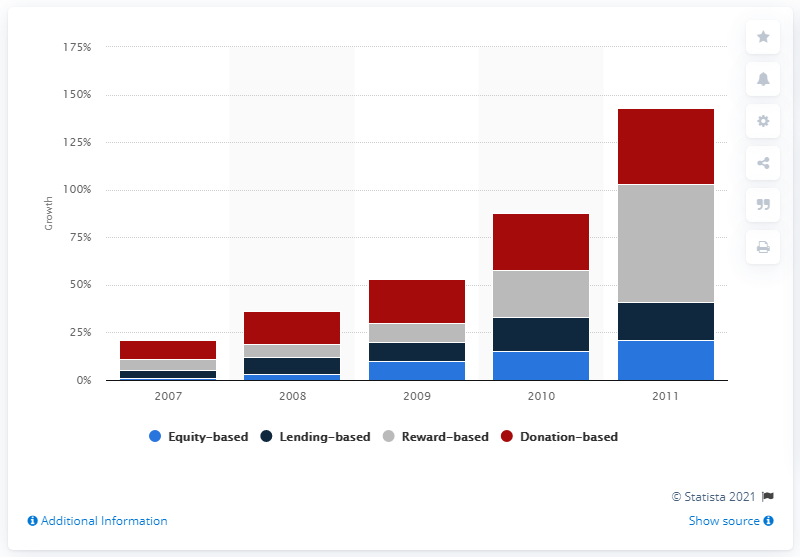Give some essential details in this illustration. In 2011, the number of equity-based crowdfunding platforms grew by 21. 